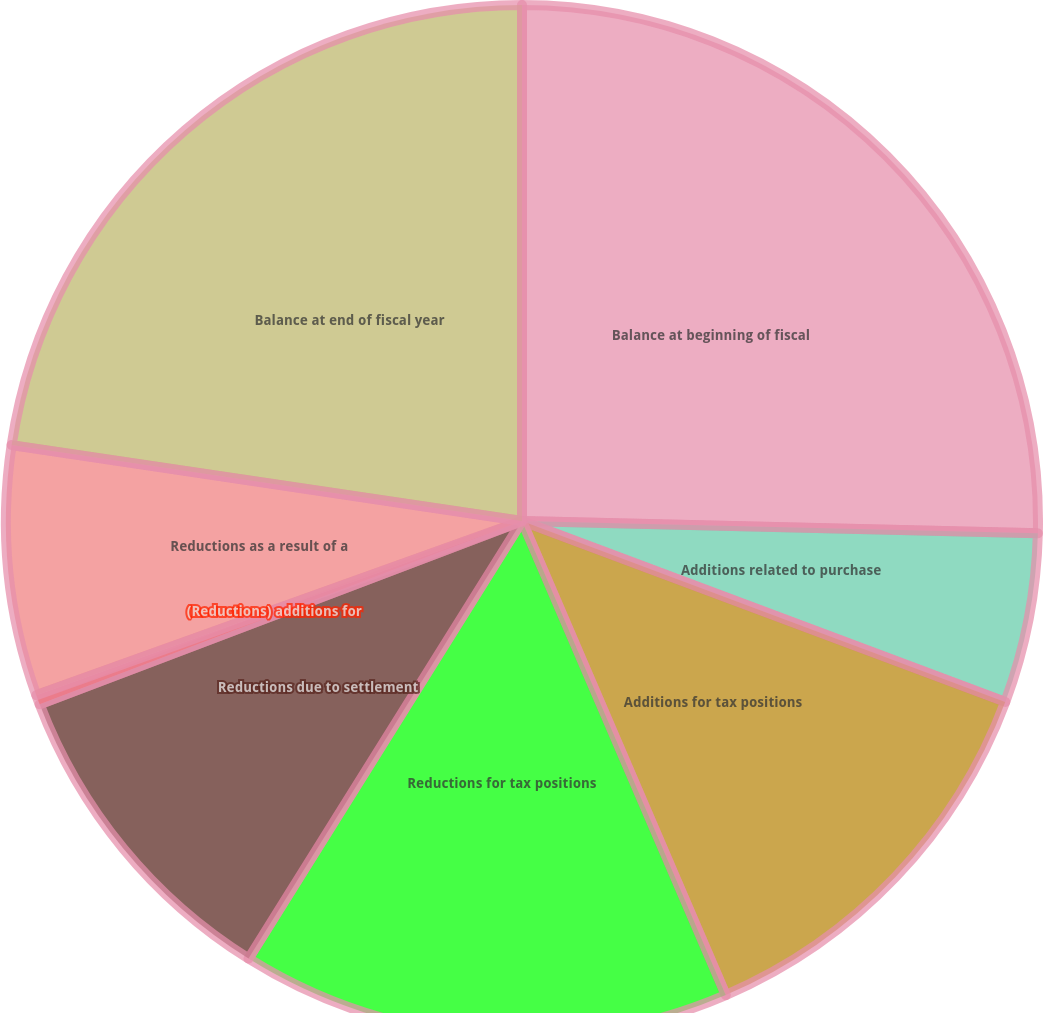Convert chart. <chart><loc_0><loc_0><loc_500><loc_500><pie_chart><fcel>Balance at beginning of fiscal<fcel>Additions related to purchase<fcel>Additions for tax positions<fcel>Reductions for tax positions<fcel>Reductions due to settlement<fcel>(Reductions) additions for<fcel>Reductions as a result of a<fcel>Balance at end of fiscal year<nl><fcel>25.38%<fcel>5.32%<fcel>12.84%<fcel>15.35%<fcel>10.33%<fcel>0.3%<fcel>7.83%<fcel>22.65%<nl></chart> 